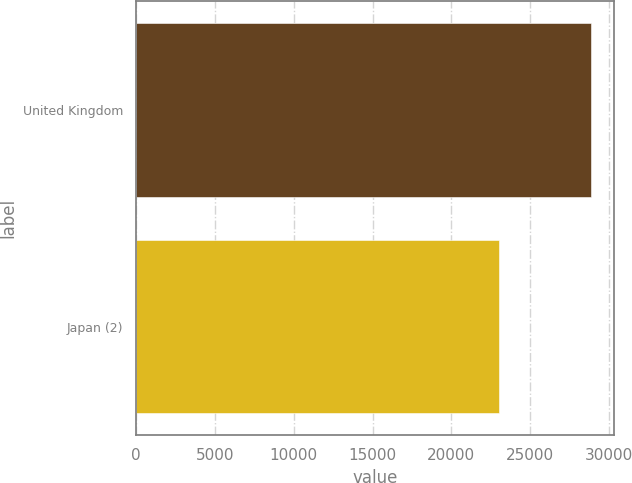Convert chart to OTSL. <chart><loc_0><loc_0><loc_500><loc_500><bar_chart><fcel>United Kingdom<fcel>Japan (2)<nl><fcel>28881<fcel>23046<nl></chart> 